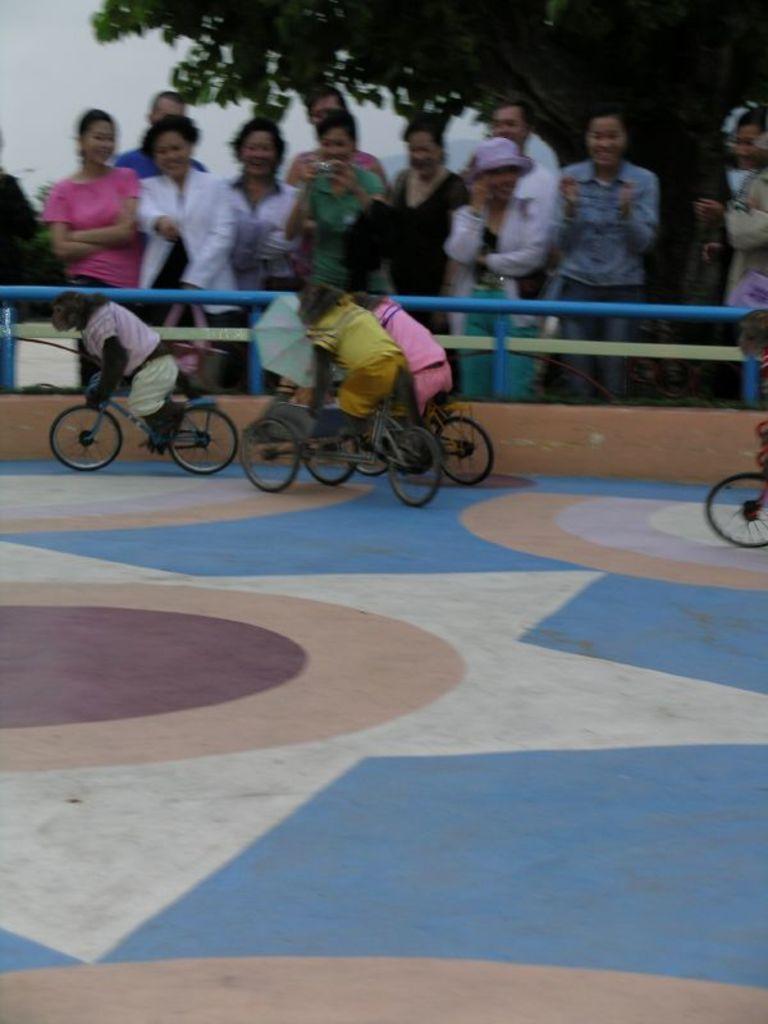Could you give a brief overview of what you see in this image? In the center of the image there are monkeys riding bicycle. In the background of the image there are people. There is tree. At the bottom of the image there is floor. 